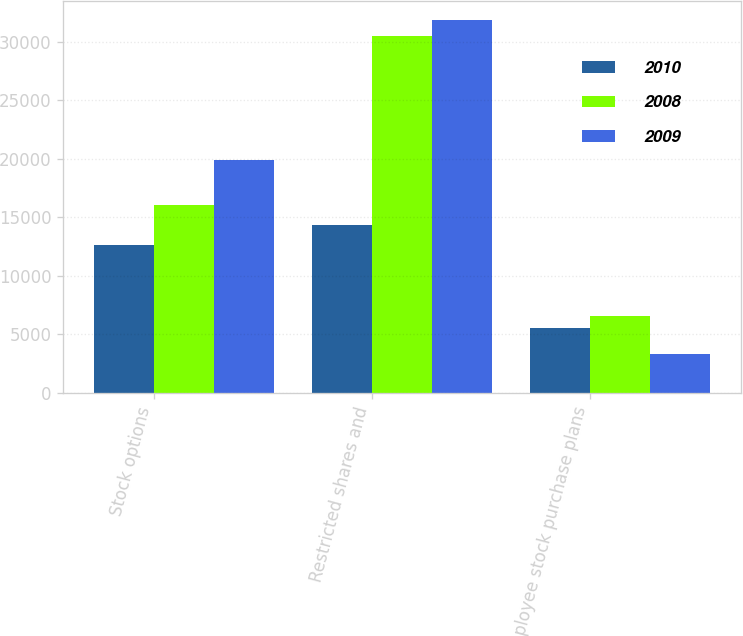Convert chart. <chart><loc_0><loc_0><loc_500><loc_500><stacked_bar_chart><ecel><fcel>Stock options<fcel>Restricted shares and<fcel>Employee stock purchase plans<nl><fcel>2010<fcel>12604<fcel>14306<fcel>5542<nl><fcel>2008<fcel>16008<fcel>30479<fcel>6569<nl><fcel>2009<fcel>19873<fcel>31899<fcel>3313<nl></chart> 